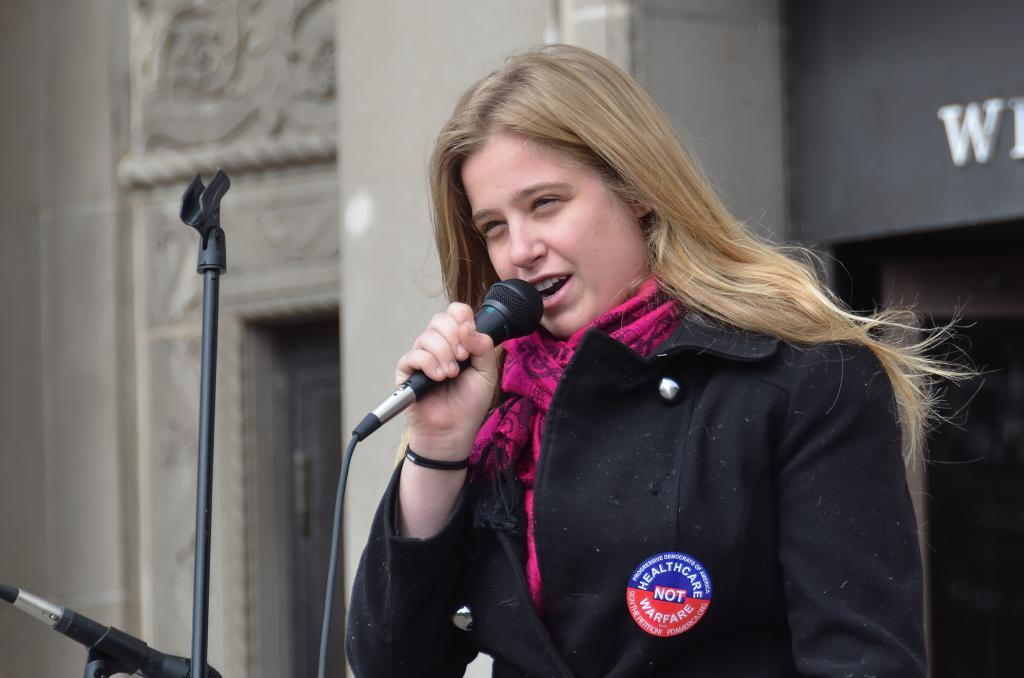Who is the main subject in the image? There is a woman in the image. What is the woman doing in the image? The woman is speaking into a microphone. How is the microphone being held in the image? The microphone is held in her hand. What is the purpose of the stand in front of the woman? The stand is likely used to support the microphone or other equipment. What type of cakes can be seen on the roof of the houses in the image? There are no houses or cakes present in the image; it features a woman speaking into a microphone. Can you hear the thunder in the background of the image? There is no mention of thunder or any sound in the image; it only shows a woman holding a microphone. 